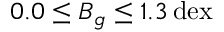<formula> <loc_0><loc_0><loc_500><loc_500>0 . 0 \leq B _ { g } \leq 1 . 3 \, d e x</formula> 